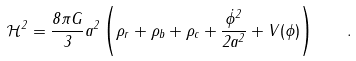<formula> <loc_0><loc_0><loc_500><loc_500>\mathcal { H } ^ { 2 } = \frac { 8 \pi G } { 3 } a ^ { 2 } \left ( \rho _ { r } + \rho _ { b } + \rho _ { c } + \frac { \dot { \phi } ^ { 2 } } { 2 a ^ { 2 } } + V ( \phi ) \right ) \quad .</formula> 